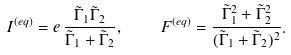Convert formula to latex. <formula><loc_0><loc_0><loc_500><loc_500>I ^ { ( e q ) } = e \, \frac { \tilde { \Gamma } _ { 1 } \tilde { \Gamma } _ { 2 } } { \tilde { \Gamma } _ { 1 } + \tilde { \Gamma } _ { 2 } } , \quad F ^ { ( e q ) } = \frac { \tilde { \Gamma } _ { 1 } ^ { 2 } + \tilde { \Gamma } _ { 2 } ^ { 2 } } { ( \tilde { \Gamma } _ { 1 } + \tilde { \Gamma } _ { 2 } ) ^ { 2 } } .</formula> 